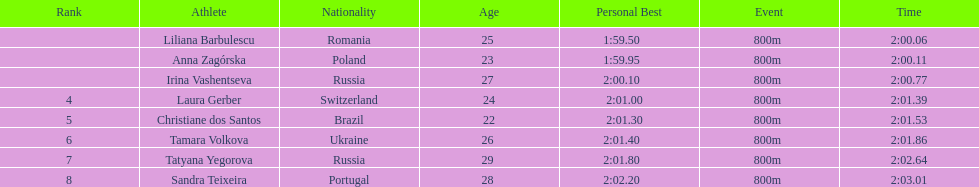How many runners finished with their time below 2:01? 3. 